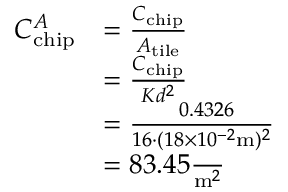<formula> <loc_0><loc_0><loc_500><loc_500>\begin{array} { r l } { C _ { c h i p } ^ { A } } & { = \frac { C _ { c h i p } } { A _ { t i l e } } } \\ & { = \frac { C _ { c h i p } } { K d ^ { 2 } } } \\ & { = \frac { \ 0 . 4 3 2 6 } { 1 6 \cdot ( 1 8 \times 1 0 ^ { - 2 } m ) ^ { 2 } } } \\ & { = 8 3 . 4 5 \frac { \ } { m ^ { 2 } } } \end{array}</formula> 